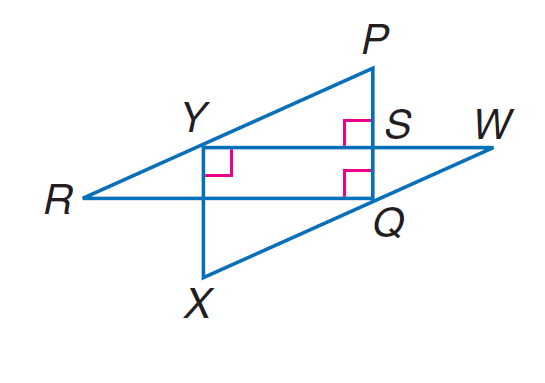Answer the mathemtical geometry problem and directly provide the correct option letter.
Question: If P R \parallel W X, W X = 10, X Y = 6, W Y = 8, R Y = 5, and P S = 3, find S Y.
Choices: A: 3 B: 4 C: 6 D: 6.5 B 